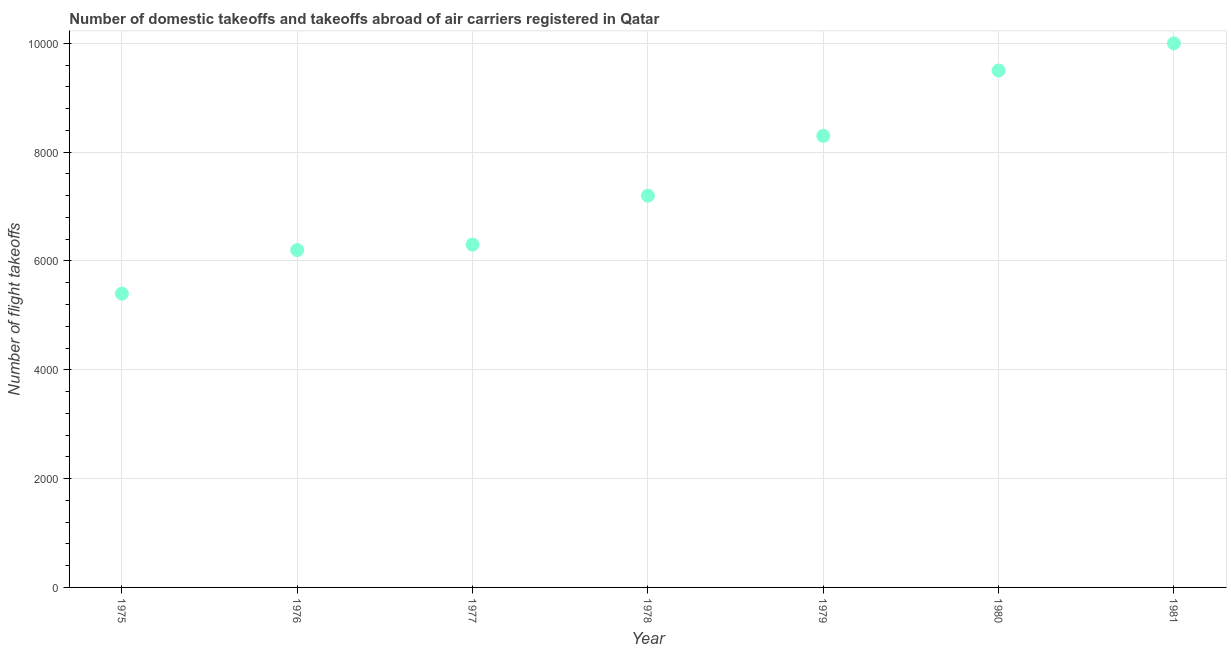What is the number of flight takeoffs in 1978?
Provide a short and direct response. 7200. Across all years, what is the maximum number of flight takeoffs?
Make the answer very short. 10000. Across all years, what is the minimum number of flight takeoffs?
Offer a very short reply. 5400. In which year was the number of flight takeoffs minimum?
Keep it short and to the point. 1975. What is the sum of the number of flight takeoffs?
Your answer should be very brief. 5.29e+04. What is the difference between the number of flight takeoffs in 1978 and 1980?
Offer a terse response. -2300. What is the average number of flight takeoffs per year?
Ensure brevity in your answer.  7557.14. What is the median number of flight takeoffs?
Your response must be concise. 7200. In how many years, is the number of flight takeoffs greater than 5200 ?
Your answer should be very brief. 7. Do a majority of the years between 1978 and 1975 (inclusive) have number of flight takeoffs greater than 4000 ?
Offer a very short reply. Yes. What is the ratio of the number of flight takeoffs in 1978 to that in 1981?
Give a very brief answer. 0.72. What is the difference between the highest and the lowest number of flight takeoffs?
Keep it short and to the point. 4600. How many dotlines are there?
Offer a terse response. 1. Does the graph contain any zero values?
Your answer should be very brief. No. Does the graph contain grids?
Give a very brief answer. Yes. What is the title of the graph?
Provide a succinct answer. Number of domestic takeoffs and takeoffs abroad of air carriers registered in Qatar. What is the label or title of the Y-axis?
Your response must be concise. Number of flight takeoffs. What is the Number of flight takeoffs in 1975?
Make the answer very short. 5400. What is the Number of flight takeoffs in 1976?
Give a very brief answer. 6200. What is the Number of flight takeoffs in 1977?
Make the answer very short. 6300. What is the Number of flight takeoffs in 1978?
Offer a very short reply. 7200. What is the Number of flight takeoffs in 1979?
Provide a short and direct response. 8300. What is the Number of flight takeoffs in 1980?
Your answer should be compact. 9500. What is the Number of flight takeoffs in 1981?
Your response must be concise. 10000. What is the difference between the Number of flight takeoffs in 1975 and 1976?
Your response must be concise. -800. What is the difference between the Number of flight takeoffs in 1975 and 1977?
Ensure brevity in your answer.  -900. What is the difference between the Number of flight takeoffs in 1975 and 1978?
Your answer should be compact. -1800. What is the difference between the Number of flight takeoffs in 1975 and 1979?
Ensure brevity in your answer.  -2900. What is the difference between the Number of flight takeoffs in 1975 and 1980?
Your response must be concise. -4100. What is the difference between the Number of flight takeoffs in 1975 and 1981?
Your answer should be compact. -4600. What is the difference between the Number of flight takeoffs in 1976 and 1977?
Ensure brevity in your answer.  -100. What is the difference between the Number of flight takeoffs in 1976 and 1978?
Offer a terse response. -1000. What is the difference between the Number of flight takeoffs in 1976 and 1979?
Offer a terse response. -2100. What is the difference between the Number of flight takeoffs in 1976 and 1980?
Provide a succinct answer. -3300. What is the difference between the Number of flight takeoffs in 1976 and 1981?
Your answer should be very brief. -3800. What is the difference between the Number of flight takeoffs in 1977 and 1978?
Your answer should be very brief. -900. What is the difference between the Number of flight takeoffs in 1977 and 1979?
Ensure brevity in your answer.  -2000. What is the difference between the Number of flight takeoffs in 1977 and 1980?
Your answer should be very brief. -3200. What is the difference between the Number of flight takeoffs in 1977 and 1981?
Keep it short and to the point. -3700. What is the difference between the Number of flight takeoffs in 1978 and 1979?
Keep it short and to the point. -1100. What is the difference between the Number of flight takeoffs in 1978 and 1980?
Offer a very short reply. -2300. What is the difference between the Number of flight takeoffs in 1978 and 1981?
Keep it short and to the point. -2800. What is the difference between the Number of flight takeoffs in 1979 and 1980?
Your answer should be very brief. -1200. What is the difference between the Number of flight takeoffs in 1979 and 1981?
Your answer should be compact. -1700. What is the difference between the Number of flight takeoffs in 1980 and 1981?
Keep it short and to the point. -500. What is the ratio of the Number of flight takeoffs in 1975 to that in 1976?
Make the answer very short. 0.87. What is the ratio of the Number of flight takeoffs in 1975 to that in 1977?
Your answer should be compact. 0.86. What is the ratio of the Number of flight takeoffs in 1975 to that in 1979?
Ensure brevity in your answer.  0.65. What is the ratio of the Number of flight takeoffs in 1975 to that in 1980?
Keep it short and to the point. 0.57. What is the ratio of the Number of flight takeoffs in 1975 to that in 1981?
Offer a terse response. 0.54. What is the ratio of the Number of flight takeoffs in 1976 to that in 1978?
Your answer should be very brief. 0.86. What is the ratio of the Number of flight takeoffs in 1976 to that in 1979?
Offer a terse response. 0.75. What is the ratio of the Number of flight takeoffs in 1976 to that in 1980?
Your answer should be compact. 0.65. What is the ratio of the Number of flight takeoffs in 1976 to that in 1981?
Keep it short and to the point. 0.62. What is the ratio of the Number of flight takeoffs in 1977 to that in 1979?
Your response must be concise. 0.76. What is the ratio of the Number of flight takeoffs in 1977 to that in 1980?
Your answer should be very brief. 0.66. What is the ratio of the Number of flight takeoffs in 1977 to that in 1981?
Ensure brevity in your answer.  0.63. What is the ratio of the Number of flight takeoffs in 1978 to that in 1979?
Your response must be concise. 0.87. What is the ratio of the Number of flight takeoffs in 1978 to that in 1980?
Offer a terse response. 0.76. What is the ratio of the Number of flight takeoffs in 1978 to that in 1981?
Make the answer very short. 0.72. What is the ratio of the Number of flight takeoffs in 1979 to that in 1980?
Give a very brief answer. 0.87. What is the ratio of the Number of flight takeoffs in 1979 to that in 1981?
Provide a short and direct response. 0.83. What is the ratio of the Number of flight takeoffs in 1980 to that in 1981?
Your response must be concise. 0.95. 